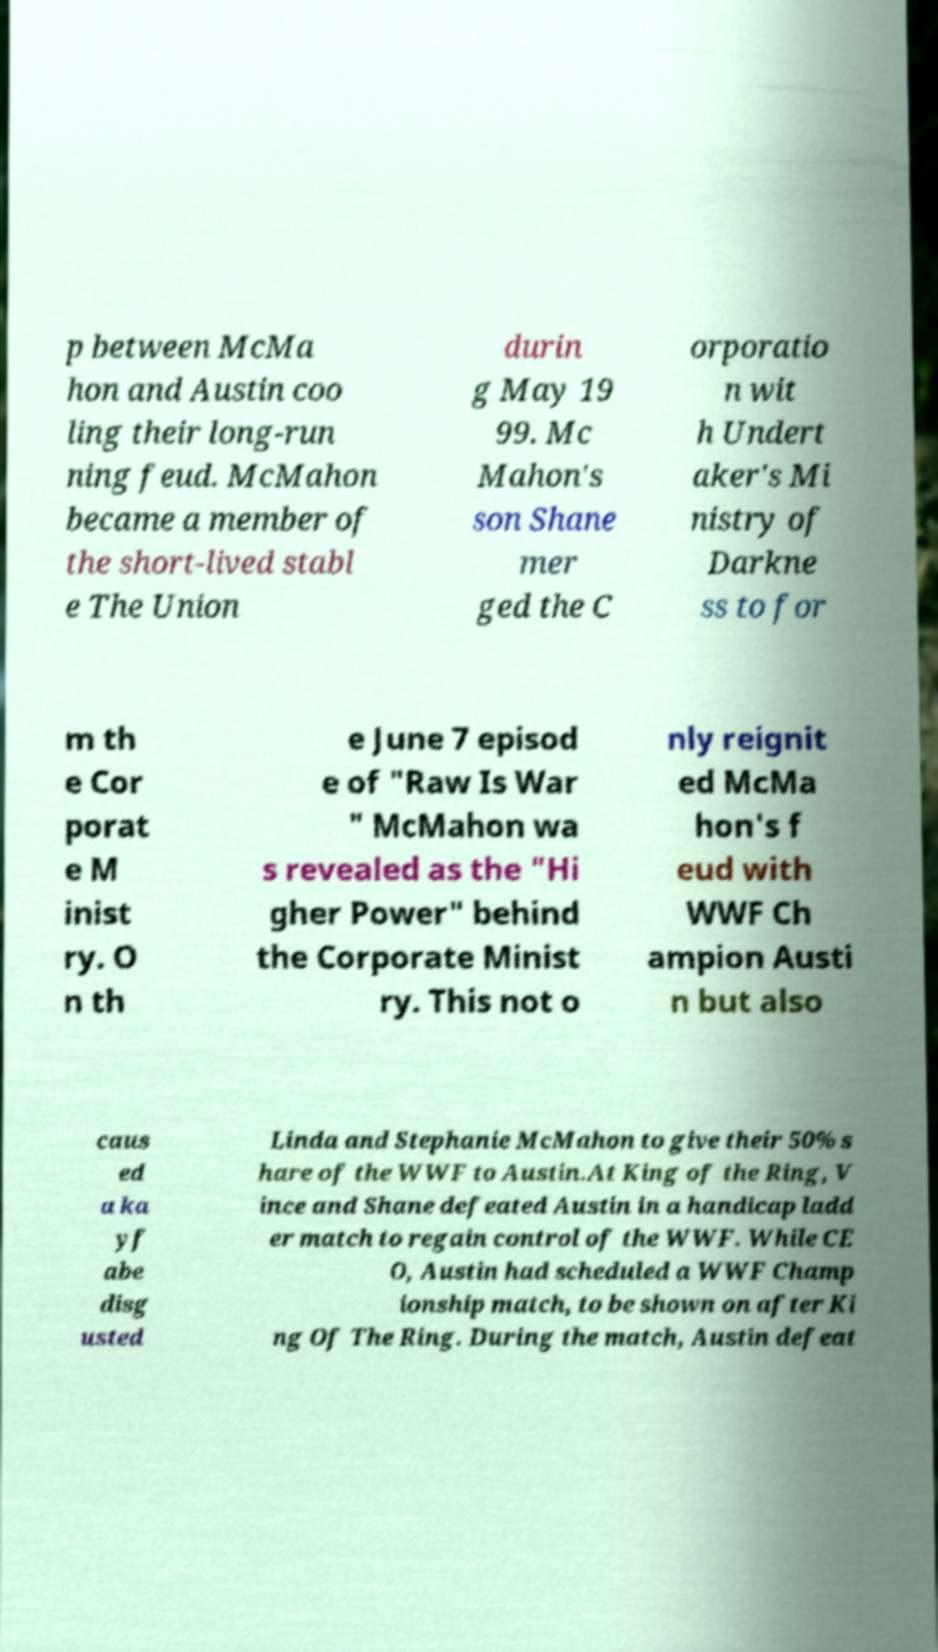For documentation purposes, I need the text within this image transcribed. Could you provide that? p between McMa hon and Austin coo ling their long-run ning feud. McMahon became a member of the short-lived stabl e The Union durin g May 19 99. Mc Mahon's son Shane mer ged the C orporatio n wit h Undert aker's Mi nistry of Darkne ss to for m th e Cor porat e M inist ry. O n th e June 7 episod e of "Raw Is War " McMahon wa s revealed as the "Hi gher Power" behind the Corporate Minist ry. This not o nly reignit ed McMa hon's f eud with WWF Ch ampion Austi n but also caus ed a ka yf abe disg usted Linda and Stephanie McMahon to give their 50% s hare of the WWF to Austin.At King of the Ring, V ince and Shane defeated Austin in a handicap ladd er match to regain control of the WWF. While CE O, Austin had scheduled a WWF Champ ionship match, to be shown on after Ki ng Of The Ring. During the match, Austin defeat 